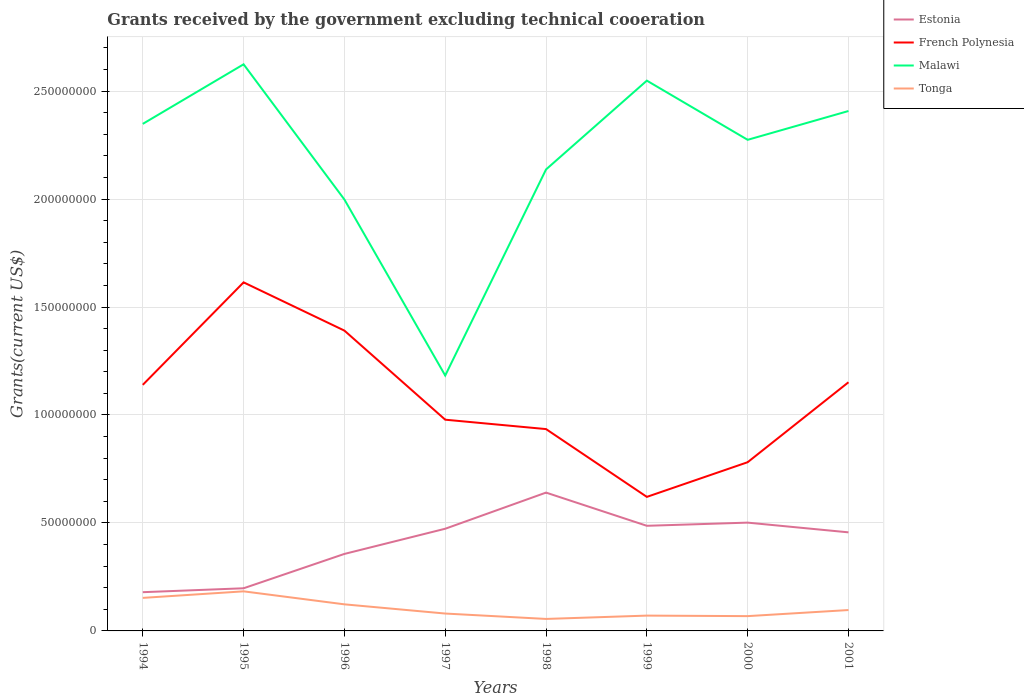Does the line corresponding to Malawi intersect with the line corresponding to Tonga?
Offer a very short reply. No. Across all years, what is the maximum total grants received by the government in Tonga?
Offer a very short reply. 5.55e+06. In which year was the total grants received by the government in Estonia maximum?
Offer a very short reply. 1994. What is the total total grants received by the government in Malawi in the graph?
Make the answer very short. -5.51e+07. What is the difference between the highest and the second highest total grants received by the government in French Polynesia?
Ensure brevity in your answer.  9.94e+07. What is the difference between the highest and the lowest total grants received by the government in French Polynesia?
Provide a succinct answer. 4. Is the total grants received by the government in Tonga strictly greater than the total grants received by the government in Malawi over the years?
Your answer should be very brief. Yes. How many years are there in the graph?
Ensure brevity in your answer.  8. Does the graph contain grids?
Your answer should be compact. Yes. Where does the legend appear in the graph?
Ensure brevity in your answer.  Top right. How many legend labels are there?
Your response must be concise. 4. How are the legend labels stacked?
Offer a very short reply. Vertical. What is the title of the graph?
Make the answer very short. Grants received by the government excluding technical cooeration. What is the label or title of the X-axis?
Give a very brief answer. Years. What is the label or title of the Y-axis?
Offer a terse response. Grants(current US$). What is the Grants(current US$) in Estonia in 1994?
Your answer should be very brief. 1.79e+07. What is the Grants(current US$) in French Polynesia in 1994?
Offer a very short reply. 1.14e+08. What is the Grants(current US$) of Malawi in 1994?
Your answer should be very brief. 2.35e+08. What is the Grants(current US$) of Tonga in 1994?
Offer a very short reply. 1.53e+07. What is the Grants(current US$) of Estonia in 1995?
Provide a short and direct response. 1.98e+07. What is the Grants(current US$) of French Polynesia in 1995?
Provide a succinct answer. 1.61e+08. What is the Grants(current US$) of Malawi in 1995?
Give a very brief answer. 2.62e+08. What is the Grants(current US$) of Tonga in 1995?
Your response must be concise. 1.83e+07. What is the Grants(current US$) of Estonia in 1996?
Give a very brief answer. 3.57e+07. What is the Grants(current US$) in French Polynesia in 1996?
Provide a succinct answer. 1.39e+08. What is the Grants(current US$) in Malawi in 1996?
Ensure brevity in your answer.  2.00e+08. What is the Grants(current US$) in Tonga in 1996?
Give a very brief answer. 1.23e+07. What is the Grants(current US$) of Estonia in 1997?
Keep it short and to the point. 4.73e+07. What is the Grants(current US$) in French Polynesia in 1997?
Provide a short and direct response. 9.78e+07. What is the Grants(current US$) in Malawi in 1997?
Give a very brief answer. 1.18e+08. What is the Grants(current US$) of Tonga in 1997?
Provide a short and direct response. 8.05e+06. What is the Grants(current US$) in Estonia in 1998?
Provide a short and direct response. 6.41e+07. What is the Grants(current US$) in French Polynesia in 1998?
Offer a terse response. 9.35e+07. What is the Grants(current US$) of Malawi in 1998?
Keep it short and to the point. 2.14e+08. What is the Grants(current US$) of Tonga in 1998?
Ensure brevity in your answer.  5.55e+06. What is the Grants(current US$) in Estonia in 1999?
Your answer should be very brief. 4.87e+07. What is the Grants(current US$) in French Polynesia in 1999?
Make the answer very short. 6.21e+07. What is the Grants(current US$) of Malawi in 1999?
Provide a succinct answer. 2.55e+08. What is the Grants(current US$) of Tonga in 1999?
Your answer should be very brief. 7.09e+06. What is the Grants(current US$) in Estonia in 2000?
Provide a succinct answer. 5.02e+07. What is the Grants(current US$) of French Polynesia in 2000?
Your response must be concise. 7.81e+07. What is the Grants(current US$) in Malawi in 2000?
Provide a short and direct response. 2.27e+08. What is the Grants(current US$) in Tonga in 2000?
Your answer should be very brief. 6.85e+06. What is the Grants(current US$) in Estonia in 2001?
Give a very brief answer. 4.56e+07. What is the Grants(current US$) in French Polynesia in 2001?
Provide a short and direct response. 1.15e+08. What is the Grants(current US$) of Malawi in 2001?
Make the answer very short. 2.41e+08. What is the Grants(current US$) of Tonga in 2001?
Your answer should be compact. 9.67e+06. Across all years, what is the maximum Grants(current US$) of Estonia?
Offer a terse response. 6.41e+07. Across all years, what is the maximum Grants(current US$) of French Polynesia?
Your response must be concise. 1.61e+08. Across all years, what is the maximum Grants(current US$) in Malawi?
Make the answer very short. 2.62e+08. Across all years, what is the maximum Grants(current US$) of Tonga?
Ensure brevity in your answer.  1.83e+07. Across all years, what is the minimum Grants(current US$) of Estonia?
Make the answer very short. 1.79e+07. Across all years, what is the minimum Grants(current US$) of French Polynesia?
Your answer should be very brief. 6.21e+07. Across all years, what is the minimum Grants(current US$) of Malawi?
Offer a terse response. 1.18e+08. Across all years, what is the minimum Grants(current US$) of Tonga?
Give a very brief answer. 5.55e+06. What is the total Grants(current US$) of Estonia in the graph?
Provide a succinct answer. 3.29e+08. What is the total Grants(current US$) in French Polynesia in the graph?
Your answer should be very brief. 8.61e+08. What is the total Grants(current US$) of Malawi in the graph?
Give a very brief answer. 1.75e+09. What is the total Grants(current US$) of Tonga in the graph?
Your answer should be compact. 8.32e+07. What is the difference between the Grants(current US$) in Estonia in 1994 and that in 1995?
Your response must be concise. -1.81e+06. What is the difference between the Grants(current US$) in French Polynesia in 1994 and that in 1995?
Make the answer very short. -4.75e+07. What is the difference between the Grants(current US$) in Malawi in 1994 and that in 1995?
Provide a succinct answer. -2.76e+07. What is the difference between the Grants(current US$) of Tonga in 1994 and that in 1995?
Offer a very short reply. -3.03e+06. What is the difference between the Grants(current US$) in Estonia in 1994 and that in 1996?
Offer a terse response. -1.77e+07. What is the difference between the Grants(current US$) of French Polynesia in 1994 and that in 1996?
Make the answer very short. -2.51e+07. What is the difference between the Grants(current US$) in Malawi in 1994 and that in 1996?
Offer a very short reply. 3.50e+07. What is the difference between the Grants(current US$) of Tonga in 1994 and that in 1996?
Provide a succinct answer. 2.99e+06. What is the difference between the Grants(current US$) of Estonia in 1994 and that in 1997?
Provide a succinct answer. -2.94e+07. What is the difference between the Grants(current US$) of French Polynesia in 1994 and that in 1997?
Ensure brevity in your answer.  1.61e+07. What is the difference between the Grants(current US$) of Malawi in 1994 and that in 1997?
Give a very brief answer. 1.17e+08. What is the difference between the Grants(current US$) of Tonga in 1994 and that in 1997?
Make the answer very short. 7.25e+06. What is the difference between the Grants(current US$) of Estonia in 1994 and that in 1998?
Offer a terse response. -4.61e+07. What is the difference between the Grants(current US$) of French Polynesia in 1994 and that in 1998?
Offer a terse response. 2.05e+07. What is the difference between the Grants(current US$) in Malawi in 1994 and that in 1998?
Give a very brief answer. 2.11e+07. What is the difference between the Grants(current US$) in Tonga in 1994 and that in 1998?
Your answer should be very brief. 9.75e+06. What is the difference between the Grants(current US$) in Estonia in 1994 and that in 1999?
Ensure brevity in your answer.  -3.07e+07. What is the difference between the Grants(current US$) in French Polynesia in 1994 and that in 1999?
Offer a terse response. 5.19e+07. What is the difference between the Grants(current US$) of Malawi in 1994 and that in 1999?
Provide a short and direct response. -2.00e+07. What is the difference between the Grants(current US$) in Tonga in 1994 and that in 1999?
Provide a short and direct response. 8.21e+06. What is the difference between the Grants(current US$) of Estonia in 1994 and that in 2000?
Your response must be concise. -3.22e+07. What is the difference between the Grants(current US$) in French Polynesia in 1994 and that in 2000?
Provide a succinct answer. 3.58e+07. What is the difference between the Grants(current US$) in Malawi in 1994 and that in 2000?
Your answer should be compact. 7.38e+06. What is the difference between the Grants(current US$) in Tonga in 1994 and that in 2000?
Keep it short and to the point. 8.45e+06. What is the difference between the Grants(current US$) of Estonia in 1994 and that in 2001?
Your answer should be compact. -2.77e+07. What is the difference between the Grants(current US$) in French Polynesia in 1994 and that in 2001?
Offer a very short reply. -1.21e+06. What is the difference between the Grants(current US$) in Malawi in 1994 and that in 2001?
Offer a very short reply. -5.96e+06. What is the difference between the Grants(current US$) in Tonga in 1994 and that in 2001?
Ensure brevity in your answer.  5.63e+06. What is the difference between the Grants(current US$) of Estonia in 1995 and that in 1996?
Offer a terse response. -1.59e+07. What is the difference between the Grants(current US$) in French Polynesia in 1995 and that in 1996?
Your answer should be very brief. 2.23e+07. What is the difference between the Grants(current US$) in Malawi in 1995 and that in 1996?
Provide a succinct answer. 6.26e+07. What is the difference between the Grants(current US$) in Tonga in 1995 and that in 1996?
Give a very brief answer. 6.02e+06. What is the difference between the Grants(current US$) in Estonia in 1995 and that in 1997?
Provide a short and direct response. -2.76e+07. What is the difference between the Grants(current US$) of French Polynesia in 1995 and that in 1997?
Your response must be concise. 6.36e+07. What is the difference between the Grants(current US$) in Malawi in 1995 and that in 1997?
Your answer should be compact. 1.44e+08. What is the difference between the Grants(current US$) of Tonga in 1995 and that in 1997?
Provide a short and direct response. 1.03e+07. What is the difference between the Grants(current US$) in Estonia in 1995 and that in 1998?
Provide a succinct answer. -4.43e+07. What is the difference between the Grants(current US$) of French Polynesia in 1995 and that in 1998?
Keep it short and to the point. 6.80e+07. What is the difference between the Grants(current US$) in Malawi in 1995 and that in 1998?
Your answer should be very brief. 4.87e+07. What is the difference between the Grants(current US$) in Tonga in 1995 and that in 1998?
Your response must be concise. 1.28e+07. What is the difference between the Grants(current US$) of Estonia in 1995 and that in 1999?
Offer a terse response. -2.89e+07. What is the difference between the Grants(current US$) of French Polynesia in 1995 and that in 1999?
Keep it short and to the point. 9.94e+07. What is the difference between the Grants(current US$) in Malawi in 1995 and that in 1999?
Your response must be concise. 7.56e+06. What is the difference between the Grants(current US$) of Tonga in 1995 and that in 1999?
Your answer should be very brief. 1.12e+07. What is the difference between the Grants(current US$) of Estonia in 1995 and that in 2000?
Give a very brief answer. -3.04e+07. What is the difference between the Grants(current US$) in French Polynesia in 1995 and that in 2000?
Give a very brief answer. 8.33e+07. What is the difference between the Grants(current US$) of Malawi in 1995 and that in 2000?
Ensure brevity in your answer.  3.50e+07. What is the difference between the Grants(current US$) of Tonga in 1995 and that in 2000?
Ensure brevity in your answer.  1.15e+07. What is the difference between the Grants(current US$) of Estonia in 1995 and that in 2001?
Keep it short and to the point. -2.59e+07. What is the difference between the Grants(current US$) of French Polynesia in 1995 and that in 2001?
Provide a short and direct response. 4.63e+07. What is the difference between the Grants(current US$) of Malawi in 1995 and that in 2001?
Provide a short and direct response. 2.16e+07. What is the difference between the Grants(current US$) of Tonga in 1995 and that in 2001?
Offer a terse response. 8.66e+06. What is the difference between the Grants(current US$) of Estonia in 1996 and that in 1997?
Ensure brevity in your answer.  -1.17e+07. What is the difference between the Grants(current US$) in French Polynesia in 1996 and that in 1997?
Your answer should be very brief. 4.13e+07. What is the difference between the Grants(current US$) in Malawi in 1996 and that in 1997?
Keep it short and to the point. 8.15e+07. What is the difference between the Grants(current US$) in Tonga in 1996 and that in 1997?
Ensure brevity in your answer.  4.26e+06. What is the difference between the Grants(current US$) of Estonia in 1996 and that in 1998?
Provide a short and direct response. -2.84e+07. What is the difference between the Grants(current US$) in French Polynesia in 1996 and that in 1998?
Offer a terse response. 4.56e+07. What is the difference between the Grants(current US$) of Malawi in 1996 and that in 1998?
Your answer should be compact. -1.39e+07. What is the difference between the Grants(current US$) of Tonga in 1996 and that in 1998?
Offer a terse response. 6.76e+06. What is the difference between the Grants(current US$) of Estonia in 1996 and that in 1999?
Your answer should be very brief. -1.30e+07. What is the difference between the Grants(current US$) of French Polynesia in 1996 and that in 1999?
Keep it short and to the point. 7.70e+07. What is the difference between the Grants(current US$) in Malawi in 1996 and that in 1999?
Your answer should be very brief. -5.51e+07. What is the difference between the Grants(current US$) in Tonga in 1996 and that in 1999?
Your answer should be compact. 5.22e+06. What is the difference between the Grants(current US$) of Estonia in 1996 and that in 2000?
Offer a terse response. -1.45e+07. What is the difference between the Grants(current US$) of French Polynesia in 1996 and that in 2000?
Your response must be concise. 6.10e+07. What is the difference between the Grants(current US$) in Malawi in 1996 and that in 2000?
Give a very brief answer. -2.76e+07. What is the difference between the Grants(current US$) in Tonga in 1996 and that in 2000?
Make the answer very short. 5.46e+06. What is the difference between the Grants(current US$) of Estonia in 1996 and that in 2001?
Your answer should be very brief. -9.99e+06. What is the difference between the Grants(current US$) of French Polynesia in 1996 and that in 2001?
Your answer should be very brief. 2.39e+07. What is the difference between the Grants(current US$) in Malawi in 1996 and that in 2001?
Offer a terse response. -4.10e+07. What is the difference between the Grants(current US$) in Tonga in 1996 and that in 2001?
Give a very brief answer. 2.64e+06. What is the difference between the Grants(current US$) of Estonia in 1997 and that in 1998?
Make the answer very short. -1.67e+07. What is the difference between the Grants(current US$) of French Polynesia in 1997 and that in 1998?
Ensure brevity in your answer.  4.35e+06. What is the difference between the Grants(current US$) of Malawi in 1997 and that in 1998?
Offer a very short reply. -9.54e+07. What is the difference between the Grants(current US$) of Tonga in 1997 and that in 1998?
Offer a terse response. 2.50e+06. What is the difference between the Grants(current US$) in Estonia in 1997 and that in 1999?
Provide a short and direct response. -1.36e+06. What is the difference between the Grants(current US$) in French Polynesia in 1997 and that in 1999?
Offer a very short reply. 3.58e+07. What is the difference between the Grants(current US$) in Malawi in 1997 and that in 1999?
Your answer should be very brief. -1.37e+08. What is the difference between the Grants(current US$) in Tonga in 1997 and that in 1999?
Your answer should be compact. 9.60e+05. What is the difference between the Grants(current US$) in Estonia in 1997 and that in 2000?
Ensure brevity in your answer.  -2.83e+06. What is the difference between the Grants(current US$) in French Polynesia in 1997 and that in 2000?
Make the answer very short. 1.97e+07. What is the difference between the Grants(current US$) of Malawi in 1997 and that in 2000?
Your response must be concise. -1.09e+08. What is the difference between the Grants(current US$) in Tonga in 1997 and that in 2000?
Your answer should be compact. 1.20e+06. What is the difference between the Grants(current US$) in Estonia in 1997 and that in 2001?
Provide a short and direct response. 1.67e+06. What is the difference between the Grants(current US$) in French Polynesia in 1997 and that in 2001?
Make the answer very short. -1.73e+07. What is the difference between the Grants(current US$) in Malawi in 1997 and that in 2001?
Ensure brevity in your answer.  -1.22e+08. What is the difference between the Grants(current US$) of Tonga in 1997 and that in 2001?
Your answer should be compact. -1.62e+06. What is the difference between the Grants(current US$) in Estonia in 1998 and that in 1999?
Provide a short and direct response. 1.54e+07. What is the difference between the Grants(current US$) of French Polynesia in 1998 and that in 1999?
Your response must be concise. 3.14e+07. What is the difference between the Grants(current US$) in Malawi in 1998 and that in 1999?
Provide a succinct answer. -4.11e+07. What is the difference between the Grants(current US$) in Tonga in 1998 and that in 1999?
Your answer should be compact. -1.54e+06. What is the difference between the Grants(current US$) in Estonia in 1998 and that in 2000?
Your answer should be very brief. 1.39e+07. What is the difference between the Grants(current US$) in French Polynesia in 1998 and that in 2000?
Your answer should be very brief. 1.53e+07. What is the difference between the Grants(current US$) in Malawi in 1998 and that in 2000?
Keep it short and to the point. -1.37e+07. What is the difference between the Grants(current US$) in Tonga in 1998 and that in 2000?
Make the answer very short. -1.30e+06. What is the difference between the Grants(current US$) of Estonia in 1998 and that in 2001?
Your answer should be very brief. 1.84e+07. What is the difference between the Grants(current US$) of French Polynesia in 1998 and that in 2001?
Ensure brevity in your answer.  -2.17e+07. What is the difference between the Grants(current US$) in Malawi in 1998 and that in 2001?
Your answer should be compact. -2.71e+07. What is the difference between the Grants(current US$) of Tonga in 1998 and that in 2001?
Make the answer very short. -4.12e+06. What is the difference between the Grants(current US$) of Estonia in 1999 and that in 2000?
Provide a short and direct response. -1.47e+06. What is the difference between the Grants(current US$) in French Polynesia in 1999 and that in 2000?
Offer a very short reply. -1.61e+07. What is the difference between the Grants(current US$) in Malawi in 1999 and that in 2000?
Keep it short and to the point. 2.74e+07. What is the difference between the Grants(current US$) in Estonia in 1999 and that in 2001?
Provide a short and direct response. 3.03e+06. What is the difference between the Grants(current US$) of French Polynesia in 1999 and that in 2001?
Offer a terse response. -5.31e+07. What is the difference between the Grants(current US$) of Malawi in 1999 and that in 2001?
Provide a succinct answer. 1.41e+07. What is the difference between the Grants(current US$) of Tonga in 1999 and that in 2001?
Make the answer very short. -2.58e+06. What is the difference between the Grants(current US$) in Estonia in 2000 and that in 2001?
Your answer should be very brief. 4.50e+06. What is the difference between the Grants(current US$) of French Polynesia in 2000 and that in 2001?
Keep it short and to the point. -3.70e+07. What is the difference between the Grants(current US$) in Malawi in 2000 and that in 2001?
Your answer should be compact. -1.33e+07. What is the difference between the Grants(current US$) in Tonga in 2000 and that in 2001?
Provide a short and direct response. -2.82e+06. What is the difference between the Grants(current US$) of Estonia in 1994 and the Grants(current US$) of French Polynesia in 1995?
Provide a short and direct response. -1.43e+08. What is the difference between the Grants(current US$) of Estonia in 1994 and the Grants(current US$) of Malawi in 1995?
Give a very brief answer. -2.44e+08. What is the difference between the Grants(current US$) in Estonia in 1994 and the Grants(current US$) in Tonga in 1995?
Keep it short and to the point. -3.90e+05. What is the difference between the Grants(current US$) of French Polynesia in 1994 and the Grants(current US$) of Malawi in 1995?
Your answer should be compact. -1.48e+08. What is the difference between the Grants(current US$) in French Polynesia in 1994 and the Grants(current US$) in Tonga in 1995?
Ensure brevity in your answer.  9.56e+07. What is the difference between the Grants(current US$) of Malawi in 1994 and the Grants(current US$) of Tonga in 1995?
Give a very brief answer. 2.16e+08. What is the difference between the Grants(current US$) in Estonia in 1994 and the Grants(current US$) in French Polynesia in 1996?
Your response must be concise. -1.21e+08. What is the difference between the Grants(current US$) of Estonia in 1994 and the Grants(current US$) of Malawi in 1996?
Ensure brevity in your answer.  -1.82e+08. What is the difference between the Grants(current US$) of Estonia in 1994 and the Grants(current US$) of Tonga in 1996?
Your response must be concise. 5.63e+06. What is the difference between the Grants(current US$) of French Polynesia in 1994 and the Grants(current US$) of Malawi in 1996?
Your answer should be compact. -8.58e+07. What is the difference between the Grants(current US$) in French Polynesia in 1994 and the Grants(current US$) in Tonga in 1996?
Your answer should be very brief. 1.02e+08. What is the difference between the Grants(current US$) of Malawi in 1994 and the Grants(current US$) of Tonga in 1996?
Your answer should be compact. 2.22e+08. What is the difference between the Grants(current US$) of Estonia in 1994 and the Grants(current US$) of French Polynesia in 1997?
Your answer should be very brief. -7.99e+07. What is the difference between the Grants(current US$) of Estonia in 1994 and the Grants(current US$) of Malawi in 1997?
Keep it short and to the point. -1.00e+08. What is the difference between the Grants(current US$) in Estonia in 1994 and the Grants(current US$) in Tonga in 1997?
Give a very brief answer. 9.89e+06. What is the difference between the Grants(current US$) in French Polynesia in 1994 and the Grants(current US$) in Malawi in 1997?
Make the answer very short. -4.32e+06. What is the difference between the Grants(current US$) of French Polynesia in 1994 and the Grants(current US$) of Tonga in 1997?
Ensure brevity in your answer.  1.06e+08. What is the difference between the Grants(current US$) of Malawi in 1994 and the Grants(current US$) of Tonga in 1997?
Your response must be concise. 2.27e+08. What is the difference between the Grants(current US$) of Estonia in 1994 and the Grants(current US$) of French Polynesia in 1998?
Offer a very short reply. -7.55e+07. What is the difference between the Grants(current US$) in Estonia in 1994 and the Grants(current US$) in Malawi in 1998?
Provide a succinct answer. -1.96e+08. What is the difference between the Grants(current US$) of Estonia in 1994 and the Grants(current US$) of Tonga in 1998?
Give a very brief answer. 1.24e+07. What is the difference between the Grants(current US$) of French Polynesia in 1994 and the Grants(current US$) of Malawi in 1998?
Offer a terse response. -9.98e+07. What is the difference between the Grants(current US$) of French Polynesia in 1994 and the Grants(current US$) of Tonga in 1998?
Give a very brief answer. 1.08e+08. What is the difference between the Grants(current US$) of Malawi in 1994 and the Grants(current US$) of Tonga in 1998?
Provide a short and direct response. 2.29e+08. What is the difference between the Grants(current US$) of Estonia in 1994 and the Grants(current US$) of French Polynesia in 1999?
Your response must be concise. -4.41e+07. What is the difference between the Grants(current US$) in Estonia in 1994 and the Grants(current US$) in Malawi in 1999?
Your response must be concise. -2.37e+08. What is the difference between the Grants(current US$) in Estonia in 1994 and the Grants(current US$) in Tonga in 1999?
Your answer should be compact. 1.08e+07. What is the difference between the Grants(current US$) of French Polynesia in 1994 and the Grants(current US$) of Malawi in 1999?
Offer a terse response. -1.41e+08. What is the difference between the Grants(current US$) of French Polynesia in 1994 and the Grants(current US$) of Tonga in 1999?
Offer a terse response. 1.07e+08. What is the difference between the Grants(current US$) in Malawi in 1994 and the Grants(current US$) in Tonga in 1999?
Offer a terse response. 2.28e+08. What is the difference between the Grants(current US$) of Estonia in 1994 and the Grants(current US$) of French Polynesia in 2000?
Your answer should be compact. -6.02e+07. What is the difference between the Grants(current US$) in Estonia in 1994 and the Grants(current US$) in Malawi in 2000?
Offer a very short reply. -2.09e+08. What is the difference between the Grants(current US$) of Estonia in 1994 and the Grants(current US$) of Tonga in 2000?
Provide a succinct answer. 1.11e+07. What is the difference between the Grants(current US$) of French Polynesia in 1994 and the Grants(current US$) of Malawi in 2000?
Ensure brevity in your answer.  -1.13e+08. What is the difference between the Grants(current US$) of French Polynesia in 1994 and the Grants(current US$) of Tonga in 2000?
Give a very brief answer. 1.07e+08. What is the difference between the Grants(current US$) of Malawi in 1994 and the Grants(current US$) of Tonga in 2000?
Provide a short and direct response. 2.28e+08. What is the difference between the Grants(current US$) of Estonia in 1994 and the Grants(current US$) of French Polynesia in 2001?
Your answer should be very brief. -9.72e+07. What is the difference between the Grants(current US$) of Estonia in 1994 and the Grants(current US$) of Malawi in 2001?
Ensure brevity in your answer.  -2.23e+08. What is the difference between the Grants(current US$) of Estonia in 1994 and the Grants(current US$) of Tonga in 2001?
Offer a terse response. 8.27e+06. What is the difference between the Grants(current US$) in French Polynesia in 1994 and the Grants(current US$) in Malawi in 2001?
Give a very brief answer. -1.27e+08. What is the difference between the Grants(current US$) in French Polynesia in 1994 and the Grants(current US$) in Tonga in 2001?
Keep it short and to the point. 1.04e+08. What is the difference between the Grants(current US$) of Malawi in 1994 and the Grants(current US$) of Tonga in 2001?
Provide a short and direct response. 2.25e+08. What is the difference between the Grants(current US$) of Estonia in 1995 and the Grants(current US$) of French Polynesia in 1996?
Your answer should be compact. -1.19e+08. What is the difference between the Grants(current US$) in Estonia in 1995 and the Grants(current US$) in Malawi in 1996?
Provide a short and direct response. -1.80e+08. What is the difference between the Grants(current US$) of Estonia in 1995 and the Grants(current US$) of Tonga in 1996?
Offer a terse response. 7.44e+06. What is the difference between the Grants(current US$) in French Polynesia in 1995 and the Grants(current US$) in Malawi in 1996?
Make the answer very short. -3.84e+07. What is the difference between the Grants(current US$) in French Polynesia in 1995 and the Grants(current US$) in Tonga in 1996?
Offer a very short reply. 1.49e+08. What is the difference between the Grants(current US$) in Malawi in 1995 and the Grants(current US$) in Tonga in 1996?
Make the answer very short. 2.50e+08. What is the difference between the Grants(current US$) in Estonia in 1995 and the Grants(current US$) in French Polynesia in 1997?
Keep it short and to the point. -7.81e+07. What is the difference between the Grants(current US$) in Estonia in 1995 and the Grants(current US$) in Malawi in 1997?
Your response must be concise. -9.85e+07. What is the difference between the Grants(current US$) of Estonia in 1995 and the Grants(current US$) of Tonga in 1997?
Make the answer very short. 1.17e+07. What is the difference between the Grants(current US$) in French Polynesia in 1995 and the Grants(current US$) in Malawi in 1997?
Offer a terse response. 4.32e+07. What is the difference between the Grants(current US$) in French Polynesia in 1995 and the Grants(current US$) in Tonga in 1997?
Your response must be concise. 1.53e+08. What is the difference between the Grants(current US$) of Malawi in 1995 and the Grants(current US$) of Tonga in 1997?
Your answer should be compact. 2.54e+08. What is the difference between the Grants(current US$) of Estonia in 1995 and the Grants(current US$) of French Polynesia in 1998?
Give a very brief answer. -7.37e+07. What is the difference between the Grants(current US$) in Estonia in 1995 and the Grants(current US$) in Malawi in 1998?
Make the answer very short. -1.94e+08. What is the difference between the Grants(current US$) in Estonia in 1995 and the Grants(current US$) in Tonga in 1998?
Offer a very short reply. 1.42e+07. What is the difference between the Grants(current US$) in French Polynesia in 1995 and the Grants(current US$) in Malawi in 1998?
Offer a terse response. -5.23e+07. What is the difference between the Grants(current US$) of French Polynesia in 1995 and the Grants(current US$) of Tonga in 1998?
Provide a succinct answer. 1.56e+08. What is the difference between the Grants(current US$) of Malawi in 1995 and the Grants(current US$) of Tonga in 1998?
Give a very brief answer. 2.57e+08. What is the difference between the Grants(current US$) in Estonia in 1995 and the Grants(current US$) in French Polynesia in 1999?
Your answer should be very brief. -4.23e+07. What is the difference between the Grants(current US$) in Estonia in 1995 and the Grants(current US$) in Malawi in 1999?
Provide a succinct answer. -2.35e+08. What is the difference between the Grants(current US$) of Estonia in 1995 and the Grants(current US$) of Tonga in 1999?
Keep it short and to the point. 1.27e+07. What is the difference between the Grants(current US$) of French Polynesia in 1995 and the Grants(current US$) of Malawi in 1999?
Provide a succinct answer. -9.34e+07. What is the difference between the Grants(current US$) in French Polynesia in 1995 and the Grants(current US$) in Tonga in 1999?
Ensure brevity in your answer.  1.54e+08. What is the difference between the Grants(current US$) in Malawi in 1995 and the Grants(current US$) in Tonga in 1999?
Your answer should be compact. 2.55e+08. What is the difference between the Grants(current US$) in Estonia in 1995 and the Grants(current US$) in French Polynesia in 2000?
Provide a succinct answer. -5.84e+07. What is the difference between the Grants(current US$) in Estonia in 1995 and the Grants(current US$) in Malawi in 2000?
Provide a short and direct response. -2.08e+08. What is the difference between the Grants(current US$) of Estonia in 1995 and the Grants(current US$) of Tonga in 2000?
Make the answer very short. 1.29e+07. What is the difference between the Grants(current US$) of French Polynesia in 1995 and the Grants(current US$) of Malawi in 2000?
Your answer should be compact. -6.60e+07. What is the difference between the Grants(current US$) of French Polynesia in 1995 and the Grants(current US$) of Tonga in 2000?
Ensure brevity in your answer.  1.55e+08. What is the difference between the Grants(current US$) in Malawi in 1995 and the Grants(current US$) in Tonga in 2000?
Your answer should be very brief. 2.56e+08. What is the difference between the Grants(current US$) of Estonia in 1995 and the Grants(current US$) of French Polynesia in 2001?
Offer a very short reply. -9.54e+07. What is the difference between the Grants(current US$) in Estonia in 1995 and the Grants(current US$) in Malawi in 2001?
Your response must be concise. -2.21e+08. What is the difference between the Grants(current US$) of Estonia in 1995 and the Grants(current US$) of Tonga in 2001?
Give a very brief answer. 1.01e+07. What is the difference between the Grants(current US$) of French Polynesia in 1995 and the Grants(current US$) of Malawi in 2001?
Offer a very short reply. -7.94e+07. What is the difference between the Grants(current US$) of French Polynesia in 1995 and the Grants(current US$) of Tonga in 2001?
Offer a very short reply. 1.52e+08. What is the difference between the Grants(current US$) in Malawi in 1995 and the Grants(current US$) in Tonga in 2001?
Make the answer very short. 2.53e+08. What is the difference between the Grants(current US$) in Estonia in 1996 and the Grants(current US$) in French Polynesia in 1997?
Provide a short and direct response. -6.22e+07. What is the difference between the Grants(current US$) in Estonia in 1996 and the Grants(current US$) in Malawi in 1997?
Provide a succinct answer. -8.26e+07. What is the difference between the Grants(current US$) of Estonia in 1996 and the Grants(current US$) of Tonga in 1997?
Offer a terse response. 2.76e+07. What is the difference between the Grants(current US$) in French Polynesia in 1996 and the Grants(current US$) in Malawi in 1997?
Ensure brevity in your answer.  2.08e+07. What is the difference between the Grants(current US$) in French Polynesia in 1996 and the Grants(current US$) in Tonga in 1997?
Make the answer very short. 1.31e+08. What is the difference between the Grants(current US$) of Malawi in 1996 and the Grants(current US$) of Tonga in 1997?
Your answer should be very brief. 1.92e+08. What is the difference between the Grants(current US$) in Estonia in 1996 and the Grants(current US$) in French Polynesia in 1998?
Your answer should be compact. -5.78e+07. What is the difference between the Grants(current US$) of Estonia in 1996 and the Grants(current US$) of Malawi in 1998?
Ensure brevity in your answer.  -1.78e+08. What is the difference between the Grants(current US$) in Estonia in 1996 and the Grants(current US$) in Tonga in 1998?
Ensure brevity in your answer.  3.01e+07. What is the difference between the Grants(current US$) of French Polynesia in 1996 and the Grants(current US$) of Malawi in 1998?
Your answer should be very brief. -7.46e+07. What is the difference between the Grants(current US$) of French Polynesia in 1996 and the Grants(current US$) of Tonga in 1998?
Your response must be concise. 1.34e+08. What is the difference between the Grants(current US$) in Malawi in 1996 and the Grants(current US$) in Tonga in 1998?
Provide a short and direct response. 1.94e+08. What is the difference between the Grants(current US$) in Estonia in 1996 and the Grants(current US$) in French Polynesia in 1999?
Provide a succinct answer. -2.64e+07. What is the difference between the Grants(current US$) in Estonia in 1996 and the Grants(current US$) in Malawi in 1999?
Make the answer very short. -2.19e+08. What is the difference between the Grants(current US$) in Estonia in 1996 and the Grants(current US$) in Tonga in 1999?
Give a very brief answer. 2.86e+07. What is the difference between the Grants(current US$) in French Polynesia in 1996 and the Grants(current US$) in Malawi in 1999?
Give a very brief answer. -1.16e+08. What is the difference between the Grants(current US$) in French Polynesia in 1996 and the Grants(current US$) in Tonga in 1999?
Your answer should be very brief. 1.32e+08. What is the difference between the Grants(current US$) of Malawi in 1996 and the Grants(current US$) of Tonga in 1999?
Keep it short and to the point. 1.93e+08. What is the difference between the Grants(current US$) in Estonia in 1996 and the Grants(current US$) in French Polynesia in 2000?
Your response must be concise. -4.25e+07. What is the difference between the Grants(current US$) of Estonia in 1996 and the Grants(current US$) of Malawi in 2000?
Your response must be concise. -1.92e+08. What is the difference between the Grants(current US$) in Estonia in 1996 and the Grants(current US$) in Tonga in 2000?
Give a very brief answer. 2.88e+07. What is the difference between the Grants(current US$) in French Polynesia in 1996 and the Grants(current US$) in Malawi in 2000?
Keep it short and to the point. -8.84e+07. What is the difference between the Grants(current US$) of French Polynesia in 1996 and the Grants(current US$) of Tonga in 2000?
Make the answer very short. 1.32e+08. What is the difference between the Grants(current US$) of Malawi in 1996 and the Grants(current US$) of Tonga in 2000?
Offer a very short reply. 1.93e+08. What is the difference between the Grants(current US$) of Estonia in 1996 and the Grants(current US$) of French Polynesia in 2001?
Give a very brief answer. -7.95e+07. What is the difference between the Grants(current US$) in Estonia in 1996 and the Grants(current US$) in Malawi in 2001?
Offer a very short reply. -2.05e+08. What is the difference between the Grants(current US$) in Estonia in 1996 and the Grants(current US$) in Tonga in 2001?
Your answer should be compact. 2.60e+07. What is the difference between the Grants(current US$) of French Polynesia in 1996 and the Grants(current US$) of Malawi in 2001?
Provide a short and direct response. -1.02e+08. What is the difference between the Grants(current US$) in French Polynesia in 1996 and the Grants(current US$) in Tonga in 2001?
Provide a succinct answer. 1.29e+08. What is the difference between the Grants(current US$) in Malawi in 1996 and the Grants(current US$) in Tonga in 2001?
Keep it short and to the point. 1.90e+08. What is the difference between the Grants(current US$) in Estonia in 1997 and the Grants(current US$) in French Polynesia in 1998?
Your answer should be very brief. -4.62e+07. What is the difference between the Grants(current US$) in Estonia in 1997 and the Grants(current US$) in Malawi in 1998?
Your response must be concise. -1.66e+08. What is the difference between the Grants(current US$) of Estonia in 1997 and the Grants(current US$) of Tonga in 1998?
Provide a short and direct response. 4.18e+07. What is the difference between the Grants(current US$) of French Polynesia in 1997 and the Grants(current US$) of Malawi in 1998?
Your response must be concise. -1.16e+08. What is the difference between the Grants(current US$) of French Polynesia in 1997 and the Grants(current US$) of Tonga in 1998?
Your response must be concise. 9.23e+07. What is the difference between the Grants(current US$) in Malawi in 1997 and the Grants(current US$) in Tonga in 1998?
Give a very brief answer. 1.13e+08. What is the difference between the Grants(current US$) of Estonia in 1997 and the Grants(current US$) of French Polynesia in 1999?
Offer a very short reply. -1.48e+07. What is the difference between the Grants(current US$) in Estonia in 1997 and the Grants(current US$) in Malawi in 1999?
Your answer should be very brief. -2.08e+08. What is the difference between the Grants(current US$) in Estonia in 1997 and the Grants(current US$) in Tonga in 1999?
Keep it short and to the point. 4.02e+07. What is the difference between the Grants(current US$) of French Polynesia in 1997 and the Grants(current US$) of Malawi in 1999?
Your response must be concise. -1.57e+08. What is the difference between the Grants(current US$) of French Polynesia in 1997 and the Grants(current US$) of Tonga in 1999?
Your answer should be very brief. 9.07e+07. What is the difference between the Grants(current US$) of Malawi in 1997 and the Grants(current US$) of Tonga in 1999?
Your response must be concise. 1.11e+08. What is the difference between the Grants(current US$) of Estonia in 1997 and the Grants(current US$) of French Polynesia in 2000?
Provide a succinct answer. -3.08e+07. What is the difference between the Grants(current US$) of Estonia in 1997 and the Grants(current US$) of Malawi in 2000?
Make the answer very short. -1.80e+08. What is the difference between the Grants(current US$) of Estonia in 1997 and the Grants(current US$) of Tonga in 2000?
Your answer should be very brief. 4.05e+07. What is the difference between the Grants(current US$) of French Polynesia in 1997 and the Grants(current US$) of Malawi in 2000?
Provide a succinct answer. -1.30e+08. What is the difference between the Grants(current US$) of French Polynesia in 1997 and the Grants(current US$) of Tonga in 2000?
Offer a terse response. 9.10e+07. What is the difference between the Grants(current US$) of Malawi in 1997 and the Grants(current US$) of Tonga in 2000?
Your response must be concise. 1.11e+08. What is the difference between the Grants(current US$) in Estonia in 1997 and the Grants(current US$) in French Polynesia in 2001?
Ensure brevity in your answer.  -6.78e+07. What is the difference between the Grants(current US$) in Estonia in 1997 and the Grants(current US$) in Malawi in 2001?
Keep it short and to the point. -1.93e+08. What is the difference between the Grants(current US$) in Estonia in 1997 and the Grants(current US$) in Tonga in 2001?
Your answer should be compact. 3.76e+07. What is the difference between the Grants(current US$) in French Polynesia in 1997 and the Grants(current US$) in Malawi in 2001?
Offer a terse response. -1.43e+08. What is the difference between the Grants(current US$) of French Polynesia in 1997 and the Grants(current US$) of Tonga in 2001?
Ensure brevity in your answer.  8.82e+07. What is the difference between the Grants(current US$) of Malawi in 1997 and the Grants(current US$) of Tonga in 2001?
Provide a succinct answer. 1.09e+08. What is the difference between the Grants(current US$) of Estonia in 1998 and the Grants(current US$) of French Polynesia in 1999?
Ensure brevity in your answer.  1.99e+06. What is the difference between the Grants(current US$) in Estonia in 1998 and the Grants(current US$) in Malawi in 1999?
Your answer should be compact. -1.91e+08. What is the difference between the Grants(current US$) in Estonia in 1998 and the Grants(current US$) in Tonga in 1999?
Offer a very short reply. 5.70e+07. What is the difference between the Grants(current US$) in French Polynesia in 1998 and the Grants(current US$) in Malawi in 1999?
Your response must be concise. -1.61e+08. What is the difference between the Grants(current US$) of French Polynesia in 1998 and the Grants(current US$) of Tonga in 1999?
Your response must be concise. 8.64e+07. What is the difference between the Grants(current US$) in Malawi in 1998 and the Grants(current US$) in Tonga in 1999?
Provide a succinct answer. 2.07e+08. What is the difference between the Grants(current US$) of Estonia in 1998 and the Grants(current US$) of French Polynesia in 2000?
Offer a terse response. -1.41e+07. What is the difference between the Grants(current US$) in Estonia in 1998 and the Grants(current US$) in Malawi in 2000?
Your answer should be compact. -1.63e+08. What is the difference between the Grants(current US$) in Estonia in 1998 and the Grants(current US$) in Tonga in 2000?
Ensure brevity in your answer.  5.72e+07. What is the difference between the Grants(current US$) in French Polynesia in 1998 and the Grants(current US$) in Malawi in 2000?
Give a very brief answer. -1.34e+08. What is the difference between the Grants(current US$) of French Polynesia in 1998 and the Grants(current US$) of Tonga in 2000?
Ensure brevity in your answer.  8.66e+07. What is the difference between the Grants(current US$) in Malawi in 1998 and the Grants(current US$) in Tonga in 2000?
Your answer should be compact. 2.07e+08. What is the difference between the Grants(current US$) of Estonia in 1998 and the Grants(current US$) of French Polynesia in 2001?
Provide a short and direct response. -5.11e+07. What is the difference between the Grants(current US$) of Estonia in 1998 and the Grants(current US$) of Malawi in 2001?
Keep it short and to the point. -1.77e+08. What is the difference between the Grants(current US$) of Estonia in 1998 and the Grants(current US$) of Tonga in 2001?
Your response must be concise. 5.44e+07. What is the difference between the Grants(current US$) of French Polynesia in 1998 and the Grants(current US$) of Malawi in 2001?
Offer a terse response. -1.47e+08. What is the difference between the Grants(current US$) of French Polynesia in 1998 and the Grants(current US$) of Tonga in 2001?
Provide a short and direct response. 8.38e+07. What is the difference between the Grants(current US$) of Malawi in 1998 and the Grants(current US$) of Tonga in 2001?
Offer a very short reply. 2.04e+08. What is the difference between the Grants(current US$) in Estonia in 1999 and the Grants(current US$) in French Polynesia in 2000?
Provide a short and direct response. -2.94e+07. What is the difference between the Grants(current US$) in Estonia in 1999 and the Grants(current US$) in Malawi in 2000?
Your answer should be compact. -1.79e+08. What is the difference between the Grants(current US$) in Estonia in 1999 and the Grants(current US$) in Tonga in 2000?
Keep it short and to the point. 4.18e+07. What is the difference between the Grants(current US$) in French Polynesia in 1999 and the Grants(current US$) in Malawi in 2000?
Your answer should be compact. -1.65e+08. What is the difference between the Grants(current US$) of French Polynesia in 1999 and the Grants(current US$) of Tonga in 2000?
Provide a short and direct response. 5.52e+07. What is the difference between the Grants(current US$) of Malawi in 1999 and the Grants(current US$) of Tonga in 2000?
Offer a terse response. 2.48e+08. What is the difference between the Grants(current US$) of Estonia in 1999 and the Grants(current US$) of French Polynesia in 2001?
Provide a succinct answer. -6.65e+07. What is the difference between the Grants(current US$) of Estonia in 1999 and the Grants(current US$) of Malawi in 2001?
Offer a very short reply. -1.92e+08. What is the difference between the Grants(current US$) in Estonia in 1999 and the Grants(current US$) in Tonga in 2001?
Offer a terse response. 3.90e+07. What is the difference between the Grants(current US$) of French Polynesia in 1999 and the Grants(current US$) of Malawi in 2001?
Offer a very short reply. -1.79e+08. What is the difference between the Grants(current US$) in French Polynesia in 1999 and the Grants(current US$) in Tonga in 2001?
Your answer should be very brief. 5.24e+07. What is the difference between the Grants(current US$) in Malawi in 1999 and the Grants(current US$) in Tonga in 2001?
Keep it short and to the point. 2.45e+08. What is the difference between the Grants(current US$) in Estonia in 2000 and the Grants(current US$) in French Polynesia in 2001?
Keep it short and to the point. -6.50e+07. What is the difference between the Grants(current US$) in Estonia in 2000 and the Grants(current US$) in Malawi in 2001?
Provide a succinct answer. -1.91e+08. What is the difference between the Grants(current US$) in Estonia in 2000 and the Grants(current US$) in Tonga in 2001?
Ensure brevity in your answer.  4.05e+07. What is the difference between the Grants(current US$) of French Polynesia in 2000 and the Grants(current US$) of Malawi in 2001?
Your response must be concise. -1.63e+08. What is the difference between the Grants(current US$) in French Polynesia in 2000 and the Grants(current US$) in Tonga in 2001?
Give a very brief answer. 6.85e+07. What is the difference between the Grants(current US$) in Malawi in 2000 and the Grants(current US$) in Tonga in 2001?
Make the answer very short. 2.18e+08. What is the average Grants(current US$) of Estonia per year?
Your response must be concise. 4.12e+07. What is the average Grants(current US$) of French Polynesia per year?
Provide a succinct answer. 1.08e+08. What is the average Grants(current US$) in Malawi per year?
Give a very brief answer. 2.19e+08. What is the average Grants(current US$) of Tonga per year?
Give a very brief answer. 1.04e+07. In the year 1994, what is the difference between the Grants(current US$) of Estonia and Grants(current US$) of French Polynesia?
Provide a succinct answer. -9.60e+07. In the year 1994, what is the difference between the Grants(current US$) of Estonia and Grants(current US$) of Malawi?
Make the answer very short. -2.17e+08. In the year 1994, what is the difference between the Grants(current US$) of Estonia and Grants(current US$) of Tonga?
Provide a short and direct response. 2.64e+06. In the year 1994, what is the difference between the Grants(current US$) of French Polynesia and Grants(current US$) of Malawi?
Your response must be concise. -1.21e+08. In the year 1994, what is the difference between the Grants(current US$) of French Polynesia and Grants(current US$) of Tonga?
Make the answer very short. 9.86e+07. In the year 1994, what is the difference between the Grants(current US$) in Malawi and Grants(current US$) in Tonga?
Your answer should be very brief. 2.20e+08. In the year 1995, what is the difference between the Grants(current US$) in Estonia and Grants(current US$) in French Polynesia?
Offer a terse response. -1.42e+08. In the year 1995, what is the difference between the Grants(current US$) of Estonia and Grants(current US$) of Malawi?
Provide a succinct answer. -2.43e+08. In the year 1995, what is the difference between the Grants(current US$) in Estonia and Grants(current US$) in Tonga?
Ensure brevity in your answer.  1.42e+06. In the year 1995, what is the difference between the Grants(current US$) in French Polynesia and Grants(current US$) in Malawi?
Offer a terse response. -1.01e+08. In the year 1995, what is the difference between the Grants(current US$) of French Polynesia and Grants(current US$) of Tonga?
Offer a terse response. 1.43e+08. In the year 1995, what is the difference between the Grants(current US$) of Malawi and Grants(current US$) of Tonga?
Make the answer very short. 2.44e+08. In the year 1996, what is the difference between the Grants(current US$) of Estonia and Grants(current US$) of French Polynesia?
Your response must be concise. -1.03e+08. In the year 1996, what is the difference between the Grants(current US$) in Estonia and Grants(current US$) in Malawi?
Offer a very short reply. -1.64e+08. In the year 1996, what is the difference between the Grants(current US$) of Estonia and Grants(current US$) of Tonga?
Your response must be concise. 2.34e+07. In the year 1996, what is the difference between the Grants(current US$) in French Polynesia and Grants(current US$) in Malawi?
Offer a very short reply. -6.07e+07. In the year 1996, what is the difference between the Grants(current US$) of French Polynesia and Grants(current US$) of Tonga?
Provide a succinct answer. 1.27e+08. In the year 1996, what is the difference between the Grants(current US$) in Malawi and Grants(current US$) in Tonga?
Ensure brevity in your answer.  1.87e+08. In the year 1997, what is the difference between the Grants(current US$) of Estonia and Grants(current US$) of French Polynesia?
Keep it short and to the point. -5.05e+07. In the year 1997, what is the difference between the Grants(current US$) in Estonia and Grants(current US$) in Malawi?
Provide a short and direct response. -7.10e+07. In the year 1997, what is the difference between the Grants(current US$) in Estonia and Grants(current US$) in Tonga?
Offer a terse response. 3.93e+07. In the year 1997, what is the difference between the Grants(current US$) of French Polynesia and Grants(current US$) of Malawi?
Provide a short and direct response. -2.04e+07. In the year 1997, what is the difference between the Grants(current US$) of French Polynesia and Grants(current US$) of Tonga?
Ensure brevity in your answer.  8.98e+07. In the year 1997, what is the difference between the Grants(current US$) of Malawi and Grants(current US$) of Tonga?
Give a very brief answer. 1.10e+08. In the year 1998, what is the difference between the Grants(current US$) of Estonia and Grants(current US$) of French Polynesia?
Make the answer very short. -2.94e+07. In the year 1998, what is the difference between the Grants(current US$) of Estonia and Grants(current US$) of Malawi?
Keep it short and to the point. -1.50e+08. In the year 1998, what is the difference between the Grants(current US$) of Estonia and Grants(current US$) of Tonga?
Your answer should be very brief. 5.85e+07. In the year 1998, what is the difference between the Grants(current US$) in French Polynesia and Grants(current US$) in Malawi?
Make the answer very short. -1.20e+08. In the year 1998, what is the difference between the Grants(current US$) in French Polynesia and Grants(current US$) in Tonga?
Your response must be concise. 8.79e+07. In the year 1998, what is the difference between the Grants(current US$) of Malawi and Grants(current US$) of Tonga?
Your answer should be very brief. 2.08e+08. In the year 1999, what is the difference between the Grants(current US$) of Estonia and Grants(current US$) of French Polynesia?
Make the answer very short. -1.34e+07. In the year 1999, what is the difference between the Grants(current US$) of Estonia and Grants(current US$) of Malawi?
Ensure brevity in your answer.  -2.06e+08. In the year 1999, what is the difference between the Grants(current US$) of Estonia and Grants(current US$) of Tonga?
Your response must be concise. 4.16e+07. In the year 1999, what is the difference between the Grants(current US$) in French Polynesia and Grants(current US$) in Malawi?
Your response must be concise. -1.93e+08. In the year 1999, what is the difference between the Grants(current US$) of French Polynesia and Grants(current US$) of Tonga?
Your answer should be very brief. 5.50e+07. In the year 1999, what is the difference between the Grants(current US$) in Malawi and Grants(current US$) in Tonga?
Your answer should be very brief. 2.48e+08. In the year 2000, what is the difference between the Grants(current US$) in Estonia and Grants(current US$) in French Polynesia?
Your response must be concise. -2.80e+07. In the year 2000, what is the difference between the Grants(current US$) of Estonia and Grants(current US$) of Malawi?
Keep it short and to the point. -1.77e+08. In the year 2000, what is the difference between the Grants(current US$) in Estonia and Grants(current US$) in Tonga?
Make the answer very short. 4.33e+07. In the year 2000, what is the difference between the Grants(current US$) of French Polynesia and Grants(current US$) of Malawi?
Provide a succinct answer. -1.49e+08. In the year 2000, what is the difference between the Grants(current US$) in French Polynesia and Grants(current US$) in Tonga?
Make the answer very short. 7.13e+07. In the year 2000, what is the difference between the Grants(current US$) in Malawi and Grants(current US$) in Tonga?
Ensure brevity in your answer.  2.21e+08. In the year 2001, what is the difference between the Grants(current US$) in Estonia and Grants(current US$) in French Polynesia?
Give a very brief answer. -6.95e+07. In the year 2001, what is the difference between the Grants(current US$) in Estonia and Grants(current US$) in Malawi?
Give a very brief answer. -1.95e+08. In the year 2001, what is the difference between the Grants(current US$) of Estonia and Grants(current US$) of Tonga?
Provide a short and direct response. 3.60e+07. In the year 2001, what is the difference between the Grants(current US$) of French Polynesia and Grants(current US$) of Malawi?
Make the answer very short. -1.26e+08. In the year 2001, what is the difference between the Grants(current US$) in French Polynesia and Grants(current US$) in Tonga?
Keep it short and to the point. 1.05e+08. In the year 2001, what is the difference between the Grants(current US$) of Malawi and Grants(current US$) of Tonga?
Ensure brevity in your answer.  2.31e+08. What is the ratio of the Grants(current US$) in Estonia in 1994 to that in 1995?
Provide a succinct answer. 0.91. What is the ratio of the Grants(current US$) in French Polynesia in 1994 to that in 1995?
Your response must be concise. 0.71. What is the ratio of the Grants(current US$) in Malawi in 1994 to that in 1995?
Your answer should be very brief. 0.89. What is the ratio of the Grants(current US$) of Tonga in 1994 to that in 1995?
Offer a terse response. 0.83. What is the ratio of the Grants(current US$) in Estonia in 1994 to that in 1996?
Provide a short and direct response. 0.5. What is the ratio of the Grants(current US$) in French Polynesia in 1994 to that in 1996?
Your response must be concise. 0.82. What is the ratio of the Grants(current US$) of Malawi in 1994 to that in 1996?
Offer a very short reply. 1.18. What is the ratio of the Grants(current US$) of Tonga in 1994 to that in 1996?
Your response must be concise. 1.24. What is the ratio of the Grants(current US$) in Estonia in 1994 to that in 1997?
Offer a terse response. 0.38. What is the ratio of the Grants(current US$) in French Polynesia in 1994 to that in 1997?
Ensure brevity in your answer.  1.16. What is the ratio of the Grants(current US$) of Malawi in 1994 to that in 1997?
Give a very brief answer. 1.99. What is the ratio of the Grants(current US$) of Tonga in 1994 to that in 1997?
Your answer should be very brief. 1.9. What is the ratio of the Grants(current US$) of Estonia in 1994 to that in 1998?
Keep it short and to the point. 0.28. What is the ratio of the Grants(current US$) of French Polynesia in 1994 to that in 1998?
Keep it short and to the point. 1.22. What is the ratio of the Grants(current US$) in Malawi in 1994 to that in 1998?
Make the answer very short. 1.1. What is the ratio of the Grants(current US$) in Tonga in 1994 to that in 1998?
Your response must be concise. 2.76. What is the ratio of the Grants(current US$) in Estonia in 1994 to that in 1999?
Your answer should be compact. 0.37. What is the ratio of the Grants(current US$) in French Polynesia in 1994 to that in 1999?
Your response must be concise. 1.84. What is the ratio of the Grants(current US$) in Malawi in 1994 to that in 1999?
Offer a very short reply. 0.92. What is the ratio of the Grants(current US$) in Tonga in 1994 to that in 1999?
Provide a succinct answer. 2.16. What is the ratio of the Grants(current US$) of Estonia in 1994 to that in 2000?
Provide a succinct answer. 0.36. What is the ratio of the Grants(current US$) of French Polynesia in 1994 to that in 2000?
Provide a succinct answer. 1.46. What is the ratio of the Grants(current US$) of Malawi in 1994 to that in 2000?
Your answer should be compact. 1.03. What is the ratio of the Grants(current US$) in Tonga in 1994 to that in 2000?
Give a very brief answer. 2.23. What is the ratio of the Grants(current US$) of Estonia in 1994 to that in 2001?
Provide a short and direct response. 0.39. What is the ratio of the Grants(current US$) in French Polynesia in 1994 to that in 2001?
Make the answer very short. 0.99. What is the ratio of the Grants(current US$) in Malawi in 1994 to that in 2001?
Your answer should be very brief. 0.98. What is the ratio of the Grants(current US$) of Tonga in 1994 to that in 2001?
Make the answer very short. 1.58. What is the ratio of the Grants(current US$) in Estonia in 1995 to that in 1996?
Offer a terse response. 0.55. What is the ratio of the Grants(current US$) in French Polynesia in 1995 to that in 1996?
Provide a succinct answer. 1.16. What is the ratio of the Grants(current US$) of Malawi in 1995 to that in 1996?
Offer a terse response. 1.31. What is the ratio of the Grants(current US$) of Tonga in 1995 to that in 1996?
Your response must be concise. 1.49. What is the ratio of the Grants(current US$) in Estonia in 1995 to that in 1997?
Offer a very short reply. 0.42. What is the ratio of the Grants(current US$) in French Polynesia in 1995 to that in 1997?
Your answer should be very brief. 1.65. What is the ratio of the Grants(current US$) of Malawi in 1995 to that in 1997?
Your answer should be very brief. 2.22. What is the ratio of the Grants(current US$) of Tonga in 1995 to that in 1997?
Keep it short and to the point. 2.28. What is the ratio of the Grants(current US$) of Estonia in 1995 to that in 1998?
Offer a terse response. 0.31. What is the ratio of the Grants(current US$) of French Polynesia in 1995 to that in 1998?
Your answer should be compact. 1.73. What is the ratio of the Grants(current US$) of Malawi in 1995 to that in 1998?
Provide a short and direct response. 1.23. What is the ratio of the Grants(current US$) in Tonga in 1995 to that in 1998?
Offer a very short reply. 3.3. What is the ratio of the Grants(current US$) in Estonia in 1995 to that in 1999?
Provide a succinct answer. 0.41. What is the ratio of the Grants(current US$) of French Polynesia in 1995 to that in 1999?
Provide a short and direct response. 2.6. What is the ratio of the Grants(current US$) in Malawi in 1995 to that in 1999?
Provide a short and direct response. 1.03. What is the ratio of the Grants(current US$) of Tonga in 1995 to that in 1999?
Keep it short and to the point. 2.59. What is the ratio of the Grants(current US$) in Estonia in 1995 to that in 2000?
Make the answer very short. 0.39. What is the ratio of the Grants(current US$) in French Polynesia in 1995 to that in 2000?
Ensure brevity in your answer.  2.07. What is the ratio of the Grants(current US$) of Malawi in 1995 to that in 2000?
Keep it short and to the point. 1.15. What is the ratio of the Grants(current US$) of Tonga in 1995 to that in 2000?
Your answer should be compact. 2.68. What is the ratio of the Grants(current US$) of Estonia in 1995 to that in 2001?
Keep it short and to the point. 0.43. What is the ratio of the Grants(current US$) of French Polynesia in 1995 to that in 2001?
Provide a succinct answer. 1.4. What is the ratio of the Grants(current US$) of Malawi in 1995 to that in 2001?
Your answer should be compact. 1.09. What is the ratio of the Grants(current US$) of Tonga in 1995 to that in 2001?
Provide a succinct answer. 1.9. What is the ratio of the Grants(current US$) in Estonia in 1996 to that in 1997?
Your answer should be very brief. 0.75. What is the ratio of the Grants(current US$) in French Polynesia in 1996 to that in 1997?
Give a very brief answer. 1.42. What is the ratio of the Grants(current US$) of Malawi in 1996 to that in 1997?
Keep it short and to the point. 1.69. What is the ratio of the Grants(current US$) in Tonga in 1996 to that in 1997?
Provide a short and direct response. 1.53. What is the ratio of the Grants(current US$) in Estonia in 1996 to that in 1998?
Keep it short and to the point. 0.56. What is the ratio of the Grants(current US$) in French Polynesia in 1996 to that in 1998?
Keep it short and to the point. 1.49. What is the ratio of the Grants(current US$) in Malawi in 1996 to that in 1998?
Keep it short and to the point. 0.93. What is the ratio of the Grants(current US$) of Tonga in 1996 to that in 1998?
Keep it short and to the point. 2.22. What is the ratio of the Grants(current US$) in Estonia in 1996 to that in 1999?
Your response must be concise. 0.73. What is the ratio of the Grants(current US$) in French Polynesia in 1996 to that in 1999?
Ensure brevity in your answer.  2.24. What is the ratio of the Grants(current US$) in Malawi in 1996 to that in 1999?
Ensure brevity in your answer.  0.78. What is the ratio of the Grants(current US$) of Tonga in 1996 to that in 1999?
Offer a very short reply. 1.74. What is the ratio of the Grants(current US$) of Estonia in 1996 to that in 2000?
Offer a very short reply. 0.71. What is the ratio of the Grants(current US$) in French Polynesia in 1996 to that in 2000?
Make the answer very short. 1.78. What is the ratio of the Grants(current US$) in Malawi in 1996 to that in 2000?
Ensure brevity in your answer.  0.88. What is the ratio of the Grants(current US$) in Tonga in 1996 to that in 2000?
Give a very brief answer. 1.8. What is the ratio of the Grants(current US$) of Estonia in 1996 to that in 2001?
Give a very brief answer. 0.78. What is the ratio of the Grants(current US$) of French Polynesia in 1996 to that in 2001?
Ensure brevity in your answer.  1.21. What is the ratio of the Grants(current US$) in Malawi in 1996 to that in 2001?
Provide a short and direct response. 0.83. What is the ratio of the Grants(current US$) in Tonga in 1996 to that in 2001?
Give a very brief answer. 1.27. What is the ratio of the Grants(current US$) in Estonia in 1997 to that in 1998?
Your answer should be very brief. 0.74. What is the ratio of the Grants(current US$) in French Polynesia in 1997 to that in 1998?
Offer a very short reply. 1.05. What is the ratio of the Grants(current US$) of Malawi in 1997 to that in 1998?
Keep it short and to the point. 0.55. What is the ratio of the Grants(current US$) of Tonga in 1997 to that in 1998?
Give a very brief answer. 1.45. What is the ratio of the Grants(current US$) of Estonia in 1997 to that in 1999?
Make the answer very short. 0.97. What is the ratio of the Grants(current US$) in French Polynesia in 1997 to that in 1999?
Offer a terse response. 1.58. What is the ratio of the Grants(current US$) of Malawi in 1997 to that in 1999?
Your answer should be compact. 0.46. What is the ratio of the Grants(current US$) in Tonga in 1997 to that in 1999?
Your answer should be compact. 1.14. What is the ratio of the Grants(current US$) of Estonia in 1997 to that in 2000?
Ensure brevity in your answer.  0.94. What is the ratio of the Grants(current US$) in French Polynesia in 1997 to that in 2000?
Offer a terse response. 1.25. What is the ratio of the Grants(current US$) in Malawi in 1997 to that in 2000?
Give a very brief answer. 0.52. What is the ratio of the Grants(current US$) in Tonga in 1997 to that in 2000?
Keep it short and to the point. 1.18. What is the ratio of the Grants(current US$) of Estonia in 1997 to that in 2001?
Ensure brevity in your answer.  1.04. What is the ratio of the Grants(current US$) of French Polynesia in 1997 to that in 2001?
Provide a short and direct response. 0.85. What is the ratio of the Grants(current US$) of Malawi in 1997 to that in 2001?
Your answer should be very brief. 0.49. What is the ratio of the Grants(current US$) in Tonga in 1997 to that in 2001?
Provide a short and direct response. 0.83. What is the ratio of the Grants(current US$) of Estonia in 1998 to that in 1999?
Make the answer very short. 1.32. What is the ratio of the Grants(current US$) of French Polynesia in 1998 to that in 1999?
Ensure brevity in your answer.  1.51. What is the ratio of the Grants(current US$) in Malawi in 1998 to that in 1999?
Offer a terse response. 0.84. What is the ratio of the Grants(current US$) in Tonga in 1998 to that in 1999?
Offer a terse response. 0.78. What is the ratio of the Grants(current US$) in Estonia in 1998 to that in 2000?
Provide a short and direct response. 1.28. What is the ratio of the Grants(current US$) in French Polynesia in 1998 to that in 2000?
Provide a succinct answer. 1.2. What is the ratio of the Grants(current US$) of Malawi in 1998 to that in 2000?
Ensure brevity in your answer.  0.94. What is the ratio of the Grants(current US$) in Tonga in 1998 to that in 2000?
Your answer should be compact. 0.81. What is the ratio of the Grants(current US$) in Estonia in 1998 to that in 2001?
Ensure brevity in your answer.  1.4. What is the ratio of the Grants(current US$) of French Polynesia in 1998 to that in 2001?
Provide a short and direct response. 0.81. What is the ratio of the Grants(current US$) of Malawi in 1998 to that in 2001?
Ensure brevity in your answer.  0.89. What is the ratio of the Grants(current US$) of Tonga in 1998 to that in 2001?
Your answer should be compact. 0.57. What is the ratio of the Grants(current US$) in Estonia in 1999 to that in 2000?
Keep it short and to the point. 0.97. What is the ratio of the Grants(current US$) in French Polynesia in 1999 to that in 2000?
Offer a very short reply. 0.79. What is the ratio of the Grants(current US$) in Malawi in 1999 to that in 2000?
Your answer should be very brief. 1.12. What is the ratio of the Grants(current US$) in Tonga in 1999 to that in 2000?
Keep it short and to the point. 1.03. What is the ratio of the Grants(current US$) of Estonia in 1999 to that in 2001?
Your answer should be compact. 1.07. What is the ratio of the Grants(current US$) in French Polynesia in 1999 to that in 2001?
Ensure brevity in your answer.  0.54. What is the ratio of the Grants(current US$) of Malawi in 1999 to that in 2001?
Keep it short and to the point. 1.06. What is the ratio of the Grants(current US$) in Tonga in 1999 to that in 2001?
Provide a short and direct response. 0.73. What is the ratio of the Grants(current US$) of Estonia in 2000 to that in 2001?
Offer a very short reply. 1.1. What is the ratio of the Grants(current US$) in French Polynesia in 2000 to that in 2001?
Your response must be concise. 0.68. What is the ratio of the Grants(current US$) in Malawi in 2000 to that in 2001?
Provide a short and direct response. 0.94. What is the ratio of the Grants(current US$) of Tonga in 2000 to that in 2001?
Your answer should be very brief. 0.71. What is the difference between the highest and the second highest Grants(current US$) in Estonia?
Your answer should be compact. 1.39e+07. What is the difference between the highest and the second highest Grants(current US$) of French Polynesia?
Give a very brief answer. 2.23e+07. What is the difference between the highest and the second highest Grants(current US$) in Malawi?
Make the answer very short. 7.56e+06. What is the difference between the highest and the second highest Grants(current US$) of Tonga?
Offer a terse response. 3.03e+06. What is the difference between the highest and the lowest Grants(current US$) in Estonia?
Your response must be concise. 4.61e+07. What is the difference between the highest and the lowest Grants(current US$) of French Polynesia?
Provide a short and direct response. 9.94e+07. What is the difference between the highest and the lowest Grants(current US$) in Malawi?
Provide a succinct answer. 1.44e+08. What is the difference between the highest and the lowest Grants(current US$) of Tonga?
Make the answer very short. 1.28e+07. 